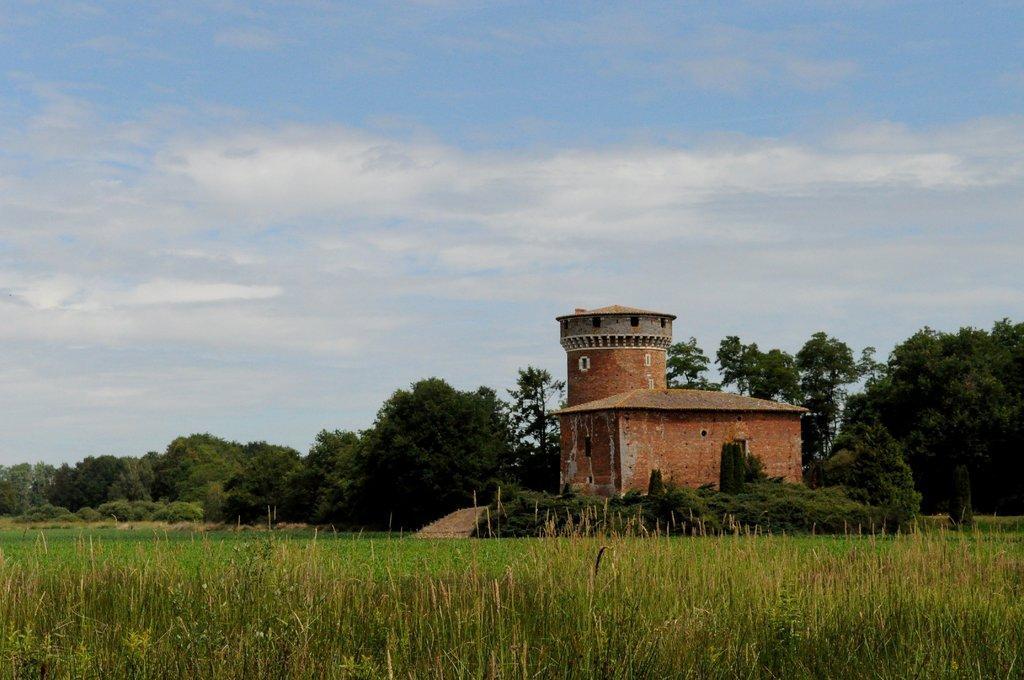Can you describe this image briefly? In the image we can see a building, grass, plant and a cloudy sky. 